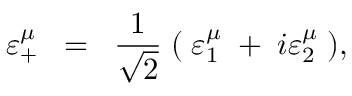<formula> <loc_0><loc_0><loc_500><loc_500>\varepsilon _ { + } ^ { \mu } \, = \, \frac { 1 } { \sqrt { 2 } } \, ( \, \varepsilon _ { 1 } ^ { \mu } \, + \, i \varepsilon _ { 2 } ^ { \mu } \, ) ,</formula> 